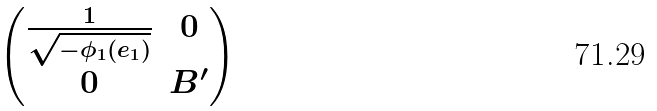Convert formula to latex. <formula><loc_0><loc_0><loc_500><loc_500>\begin{pmatrix} \frac { 1 } { \sqrt { - \phi _ { 1 } ( e _ { 1 } ) } } & 0 \\ 0 & B ^ { \prime } \end{pmatrix}</formula> 